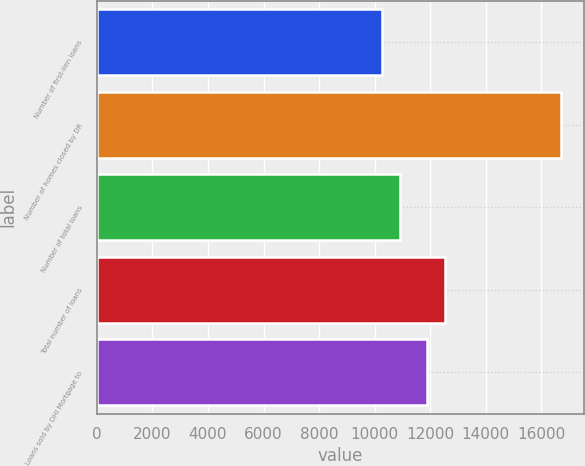<chart> <loc_0><loc_0><loc_500><loc_500><bar_chart><fcel>Number of first-lien loans<fcel>Number of homes closed by DR<fcel>Number of total loans<fcel>Total number of loans<fcel>Loans sold by DHI Mortgage to<nl><fcel>10262<fcel>16695<fcel>10905.3<fcel>12531.3<fcel>11888<nl></chart> 